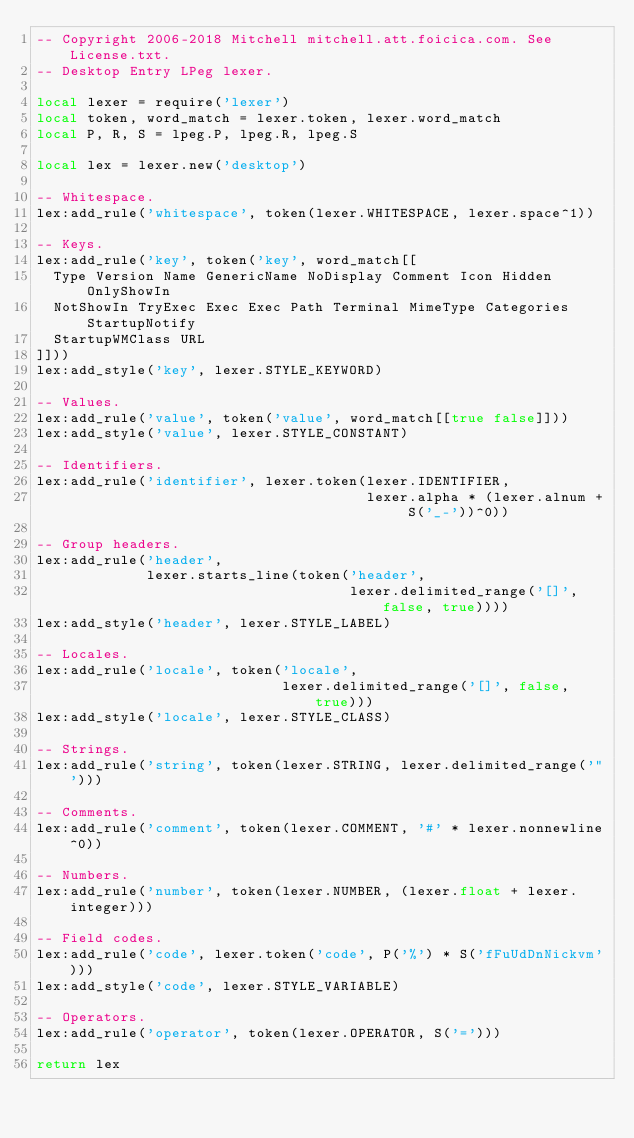<code> <loc_0><loc_0><loc_500><loc_500><_Lua_>-- Copyright 2006-2018 Mitchell mitchell.att.foicica.com. See License.txt.
-- Desktop Entry LPeg lexer.

local lexer = require('lexer')
local token, word_match = lexer.token, lexer.word_match
local P, R, S = lpeg.P, lpeg.R, lpeg.S

local lex = lexer.new('desktop')

-- Whitespace.
lex:add_rule('whitespace', token(lexer.WHITESPACE, lexer.space^1))

-- Keys.
lex:add_rule('key', token('key', word_match[[
  Type Version Name GenericName NoDisplay Comment Icon Hidden OnlyShowIn
  NotShowIn TryExec Exec Exec Path Terminal MimeType Categories StartupNotify
  StartupWMClass URL
]]))
lex:add_style('key', lexer.STYLE_KEYWORD)

-- Values.
lex:add_rule('value', token('value', word_match[[true false]]))
lex:add_style('value', lexer.STYLE_CONSTANT)

-- Identifiers.
lex:add_rule('identifier', lexer.token(lexer.IDENTIFIER,
                                       lexer.alpha * (lexer.alnum + S('_-'))^0))

-- Group headers.
lex:add_rule('header',
             lexer.starts_line(token('header',
                                     lexer.delimited_range('[]', false, true))))
lex:add_style('header', lexer.STYLE_LABEL)

-- Locales.
lex:add_rule('locale', token('locale',
                             lexer.delimited_range('[]', false, true)))
lex:add_style('locale', lexer.STYLE_CLASS)

-- Strings.
lex:add_rule('string', token(lexer.STRING, lexer.delimited_range('"')))

-- Comments.
lex:add_rule('comment', token(lexer.COMMENT, '#' * lexer.nonnewline^0))

-- Numbers.
lex:add_rule('number', token(lexer.NUMBER, (lexer.float + lexer.integer)))

-- Field codes.
lex:add_rule('code', lexer.token('code', P('%') * S('fFuUdDnNickvm')))
lex:add_style('code', lexer.STYLE_VARIABLE)

-- Operators.
lex:add_rule('operator', token(lexer.OPERATOR, S('=')))

return lex
</code> 